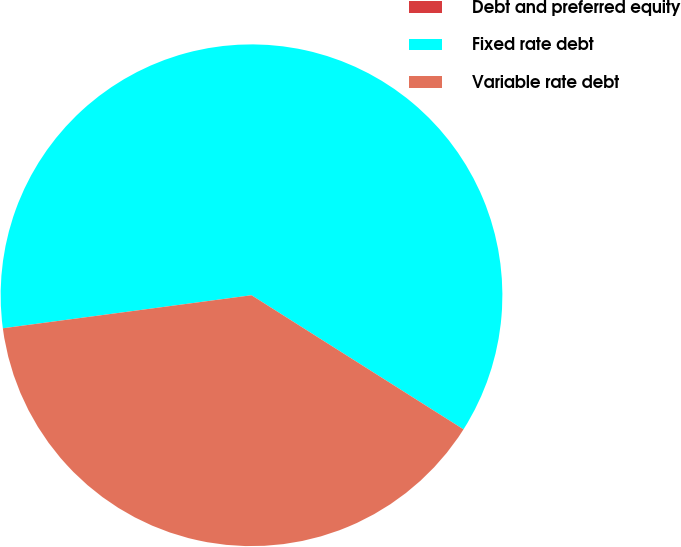Convert chart to OTSL. <chart><loc_0><loc_0><loc_500><loc_500><pie_chart><fcel>Debt and preferred equity<fcel>Fixed rate debt<fcel>Variable rate debt<nl><fcel>0.0%<fcel>61.08%<fcel>38.92%<nl></chart> 